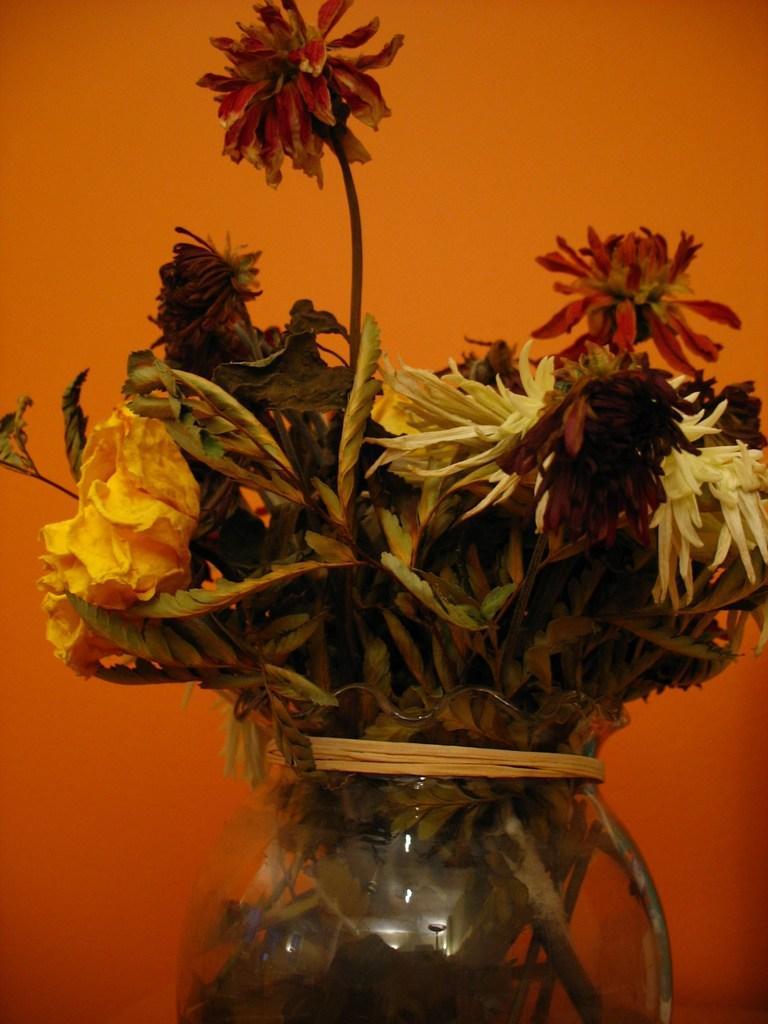Can you describe this image briefly? This image is taken indoors. In the background there is a wall. In the middle of the image there is a flower vase with flowers in it. 